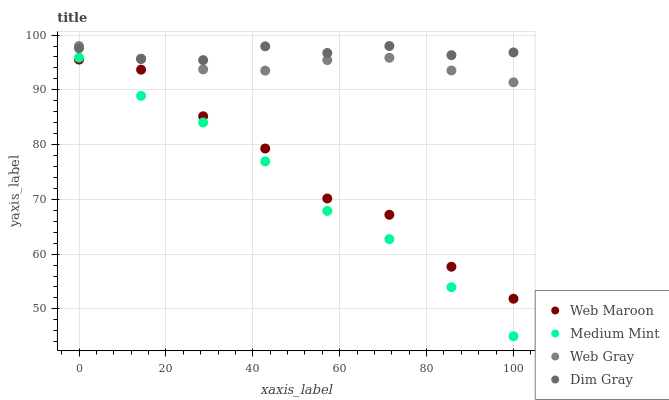Does Medium Mint have the minimum area under the curve?
Answer yes or no. Yes. Does Dim Gray have the maximum area under the curve?
Answer yes or no. Yes. Does Web Gray have the minimum area under the curve?
Answer yes or no. No. Does Web Gray have the maximum area under the curve?
Answer yes or no. No. Is Web Gray the smoothest?
Answer yes or no. Yes. Is Web Maroon the roughest?
Answer yes or no. Yes. Is Dim Gray the smoothest?
Answer yes or no. No. Is Dim Gray the roughest?
Answer yes or no. No. Does Medium Mint have the lowest value?
Answer yes or no. Yes. Does Web Gray have the lowest value?
Answer yes or no. No. Does Web Gray have the highest value?
Answer yes or no. Yes. Does Web Maroon have the highest value?
Answer yes or no. No. Is Medium Mint less than Dim Gray?
Answer yes or no. Yes. Is Dim Gray greater than Medium Mint?
Answer yes or no. Yes. Does Dim Gray intersect Web Gray?
Answer yes or no. Yes. Is Dim Gray less than Web Gray?
Answer yes or no. No. Is Dim Gray greater than Web Gray?
Answer yes or no. No. Does Medium Mint intersect Dim Gray?
Answer yes or no. No. 